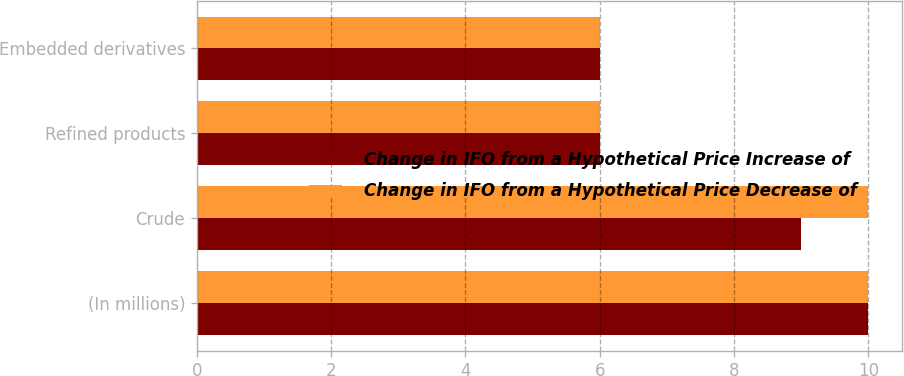Convert chart to OTSL. <chart><loc_0><loc_0><loc_500><loc_500><stacked_bar_chart><ecel><fcel>(In millions)<fcel>Crude<fcel>Refined products<fcel>Embedded derivatives<nl><fcel>Change in IFO from a Hypothetical Price Increase of<fcel>10<fcel>9<fcel>6<fcel>6<nl><fcel>Change in IFO from a Hypothetical Price Decrease of<fcel>10<fcel>10<fcel>6<fcel>6<nl></chart> 